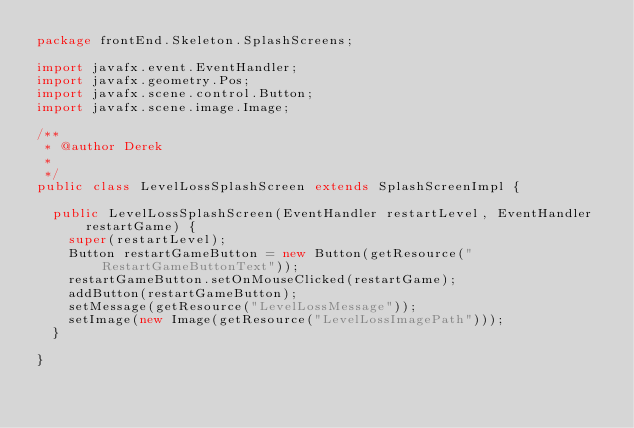Convert code to text. <code><loc_0><loc_0><loc_500><loc_500><_Java_>package frontEnd.Skeleton.SplashScreens;

import javafx.event.EventHandler;
import javafx.geometry.Pos;
import javafx.scene.control.Button;
import javafx.scene.image.Image;

/**
 * @author Derek
 *
 */
public class LevelLossSplashScreen extends SplashScreenImpl {

	public LevelLossSplashScreen(EventHandler restartLevel, EventHandler restartGame) {
		super(restartLevel);
		Button restartGameButton = new Button(getResource("RestartGameButtonText"));
		restartGameButton.setOnMouseClicked(restartGame);
		addButton(restartGameButton);
		setMessage(getResource("LevelLossMessage"));
		setImage(new Image(getResource("LevelLossImagePath")));
	}

}
</code> 